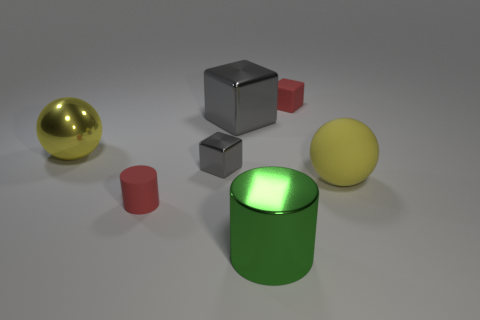There is a large object that is the same color as the large matte ball; what shape is it?
Your response must be concise. Sphere. How many cubes are either green objects or tiny matte things?
Ensure brevity in your answer.  1. What number of rubber spheres are behind the thing that is in front of the small rubber object that is in front of the big yellow matte thing?
Make the answer very short. 1. There is a matte object that is the same size as the green metallic thing; what color is it?
Offer a terse response. Yellow. What number of other objects are there of the same color as the matte sphere?
Provide a succinct answer. 1. Are there more metallic objects on the left side of the small gray thing than blue matte balls?
Your answer should be compact. Yes. Are the big green cylinder and the tiny cylinder made of the same material?
Give a very brief answer. No. What number of things are large things right of the tiny rubber cylinder or large yellow objects?
Your response must be concise. 4. How many other things are there of the same size as the yellow metal sphere?
Keep it short and to the point. 3. Is the number of shiny things that are behind the big yellow metal ball the same as the number of big metallic cubes that are to the left of the red cube?
Give a very brief answer. Yes. 